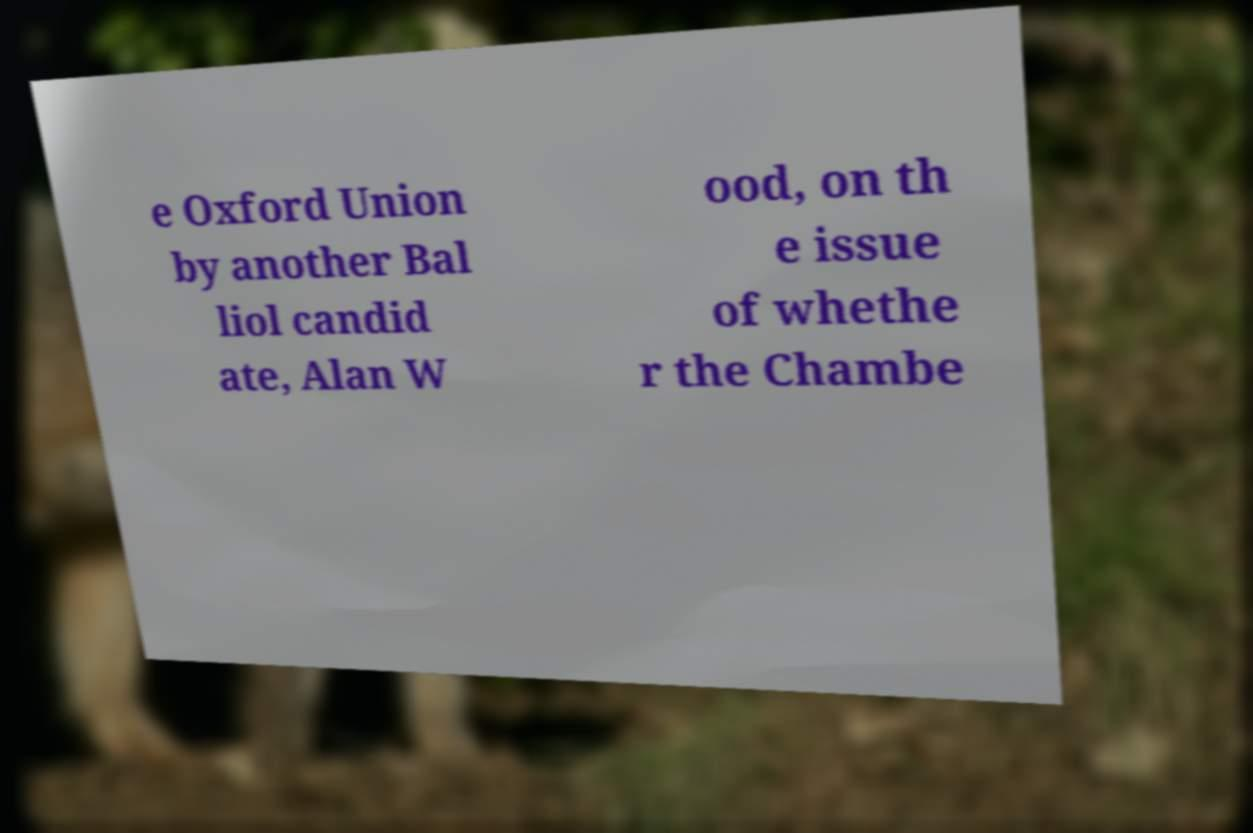Could you extract and type out the text from this image? e Oxford Union by another Bal liol candid ate, Alan W ood, on th e issue of whethe r the Chambe 